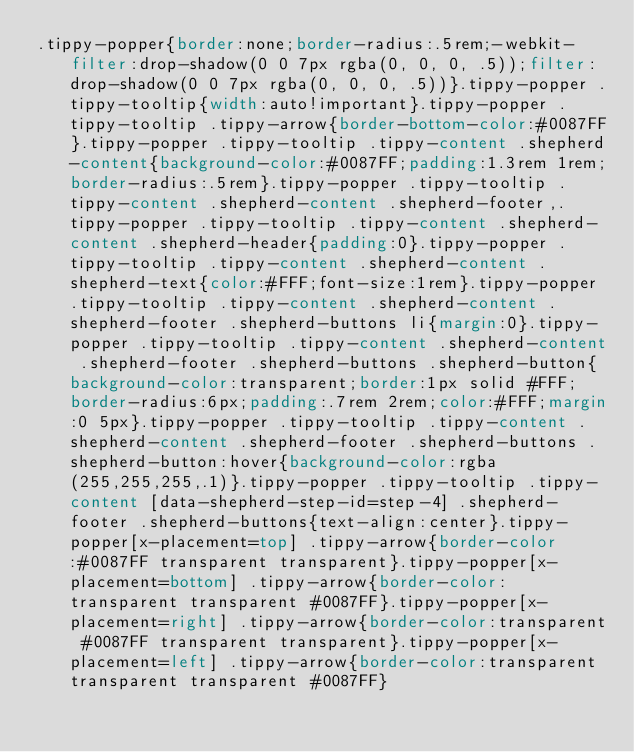Convert code to text. <code><loc_0><loc_0><loc_500><loc_500><_CSS_>.tippy-popper{border:none;border-radius:.5rem;-webkit-filter:drop-shadow(0 0 7px rgba(0, 0, 0, .5));filter:drop-shadow(0 0 7px rgba(0, 0, 0, .5))}.tippy-popper .tippy-tooltip{width:auto!important}.tippy-popper .tippy-tooltip .tippy-arrow{border-bottom-color:#0087FF}.tippy-popper .tippy-tooltip .tippy-content .shepherd-content{background-color:#0087FF;padding:1.3rem 1rem;border-radius:.5rem}.tippy-popper .tippy-tooltip .tippy-content .shepherd-content .shepherd-footer,.tippy-popper .tippy-tooltip .tippy-content .shepherd-content .shepherd-header{padding:0}.tippy-popper .tippy-tooltip .tippy-content .shepherd-content .shepherd-text{color:#FFF;font-size:1rem}.tippy-popper .tippy-tooltip .tippy-content .shepherd-content .shepherd-footer .shepherd-buttons li{margin:0}.tippy-popper .tippy-tooltip .tippy-content .shepherd-content .shepherd-footer .shepherd-buttons .shepherd-button{background-color:transparent;border:1px solid #FFF;border-radius:6px;padding:.7rem 2rem;color:#FFF;margin:0 5px}.tippy-popper .tippy-tooltip .tippy-content .shepherd-content .shepherd-footer .shepherd-buttons .shepherd-button:hover{background-color:rgba(255,255,255,.1)}.tippy-popper .tippy-tooltip .tippy-content [data-shepherd-step-id=step-4] .shepherd-footer .shepherd-buttons{text-align:center}.tippy-popper[x-placement=top] .tippy-arrow{border-color:#0087FF transparent transparent}.tippy-popper[x-placement=bottom] .tippy-arrow{border-color:transparent transparent #0087FF}.tippy-popper[x-placement=right] .tippy-arrow{border-color:transparent #0087FF transparent transparent}.tippy-popper[x-placement=left] .tippy-arrow{border-color:transparent transparent transparent #0087FF}</code> 